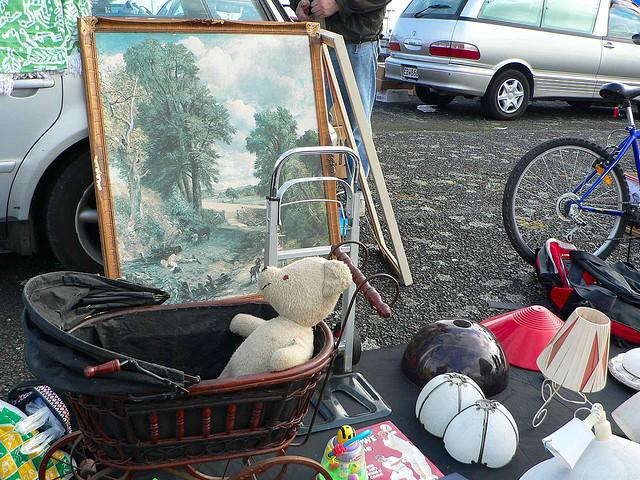This umbrellas used in which lamp?

Choices:
A) noon
B) day
C) night
D) evening night 